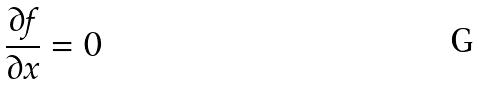Convert formula to latex. <formula><loc_0><loc_0><loc_500><loc_500>\frac { \partial f } { \partial x } = 0</formula> 